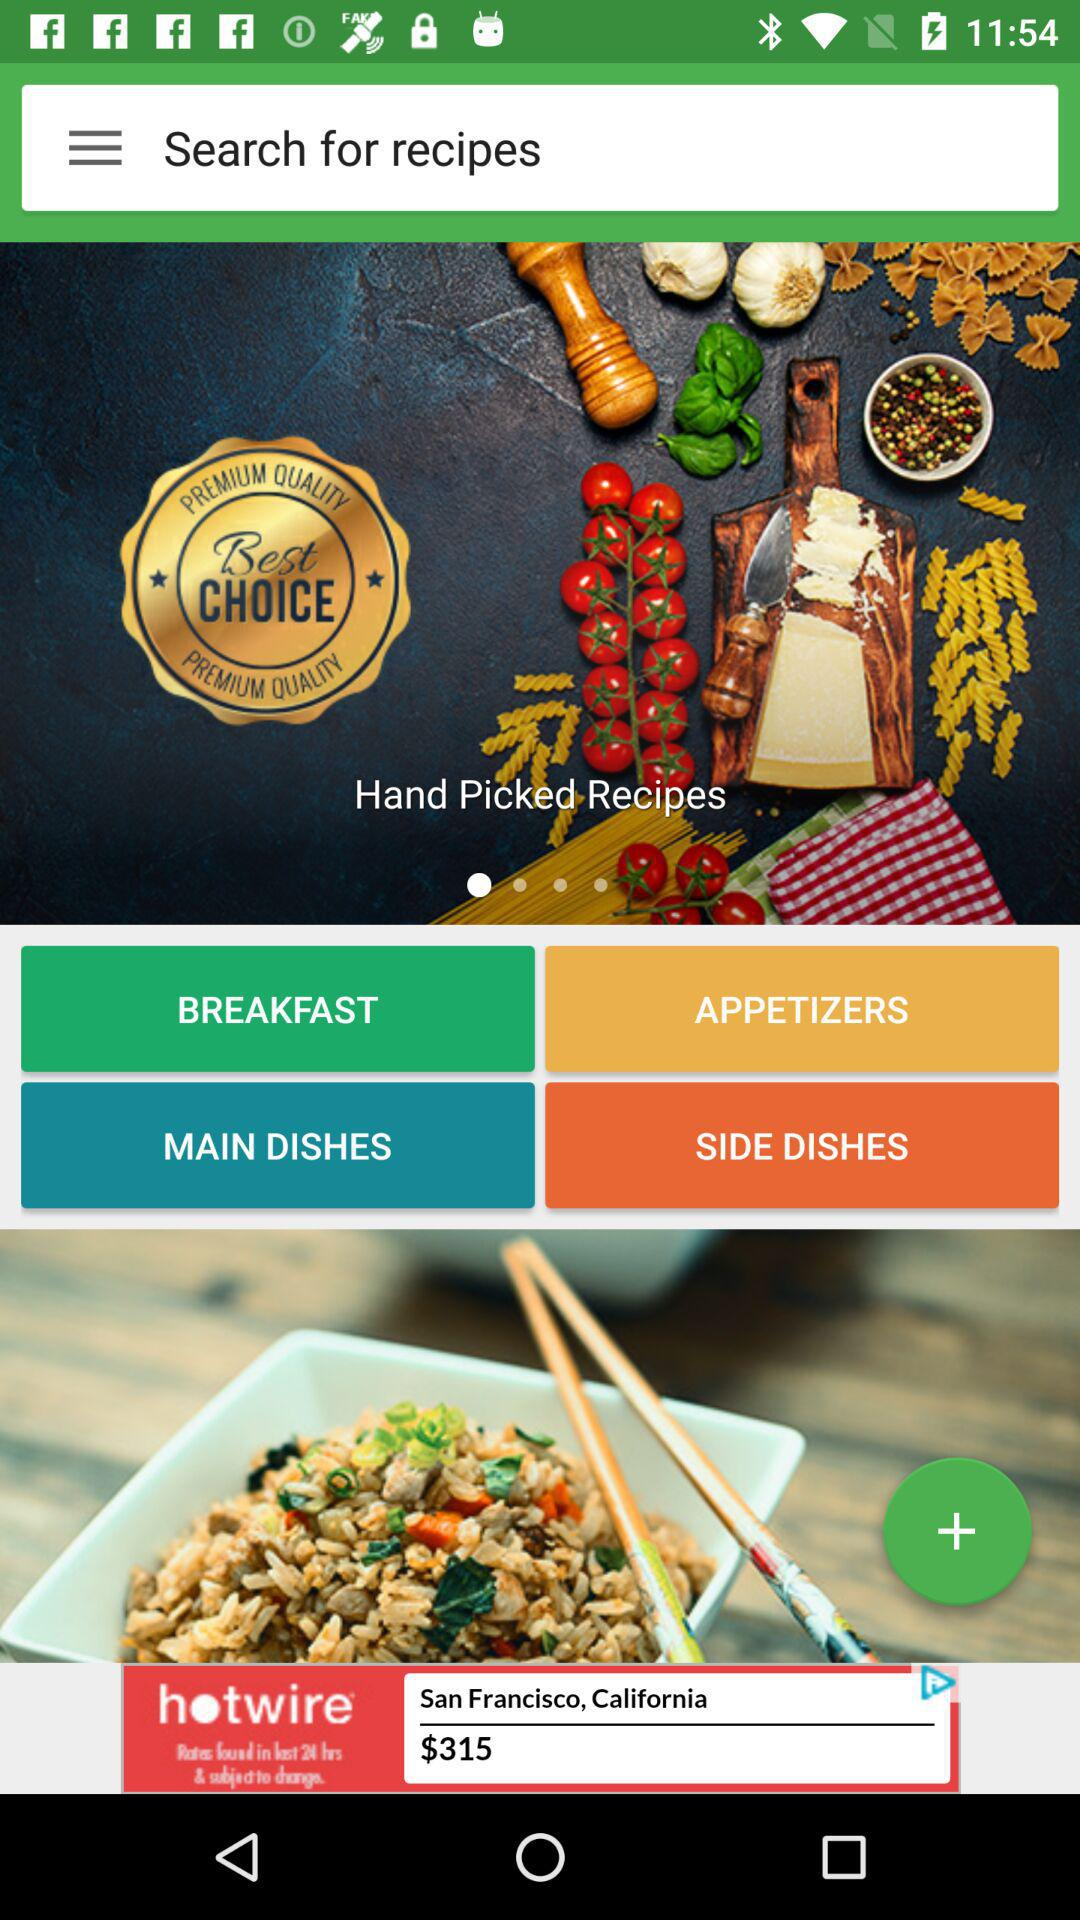Which hand-picked recipes are displayed?
When the provided information is insufficient, respond with <no answer>. <no answer> 